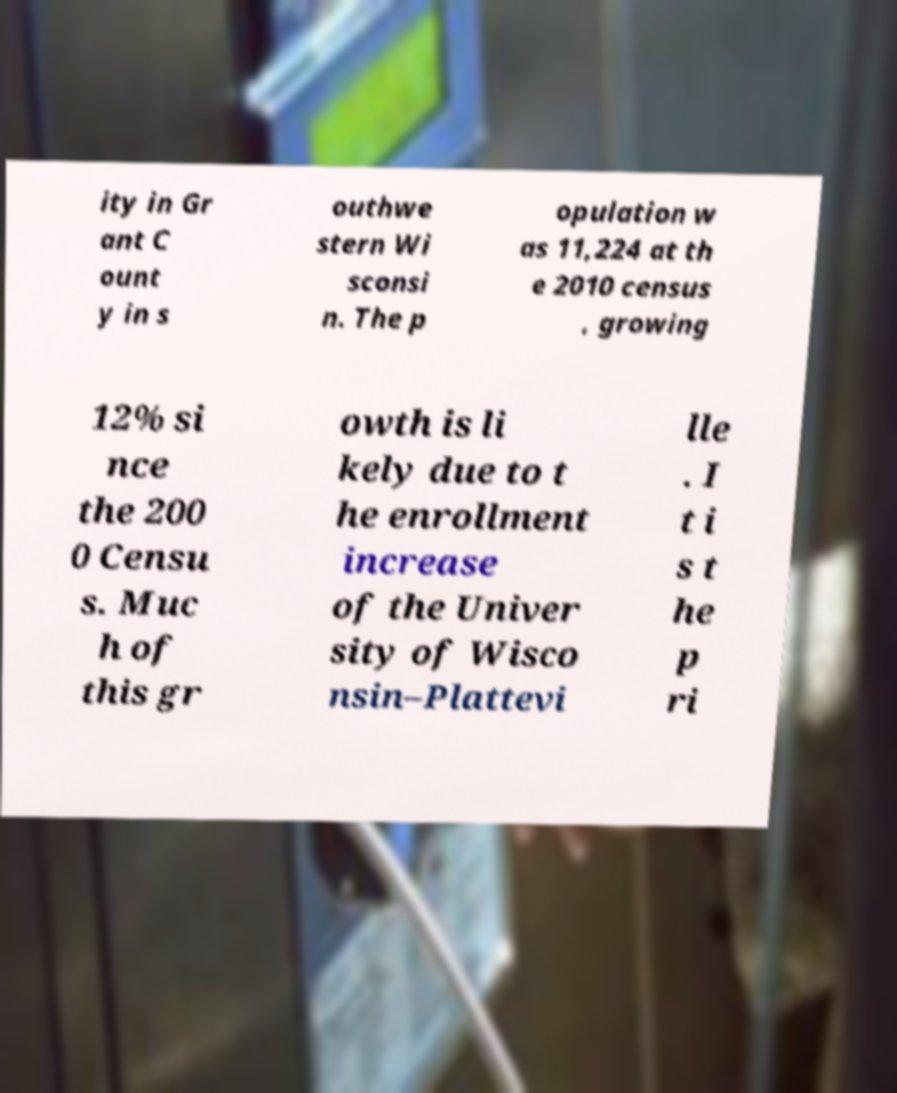I need the written content from this picture converted into text. Can you do that? ity in Gr ant C ount y in s outhwe stern Wi sconsi n. The p opulation w as 11,224 at th e 2010 census , growing 12% si nce the 200 0 Censu s. Muc h of this gr owth is li kely due to t he enrollment increase of the Univer sity of Wisco nsin–Plattevi lle . I t i s t he p ri 